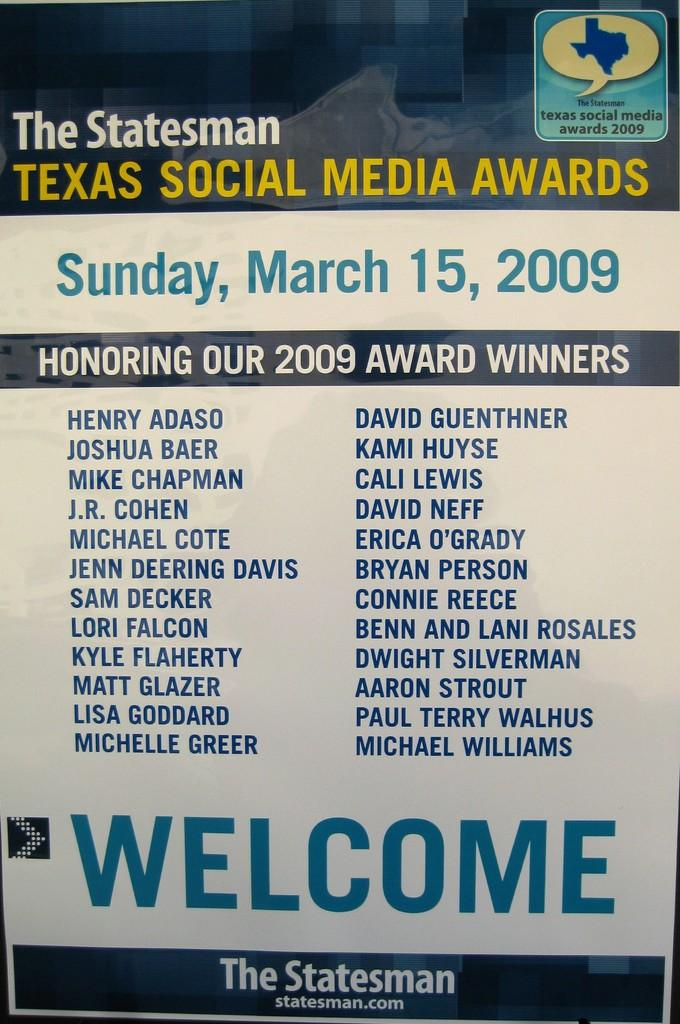Provide a one-sentence caption for the provided image. A welcome pamphlet to the Texas Social Media Awards. 